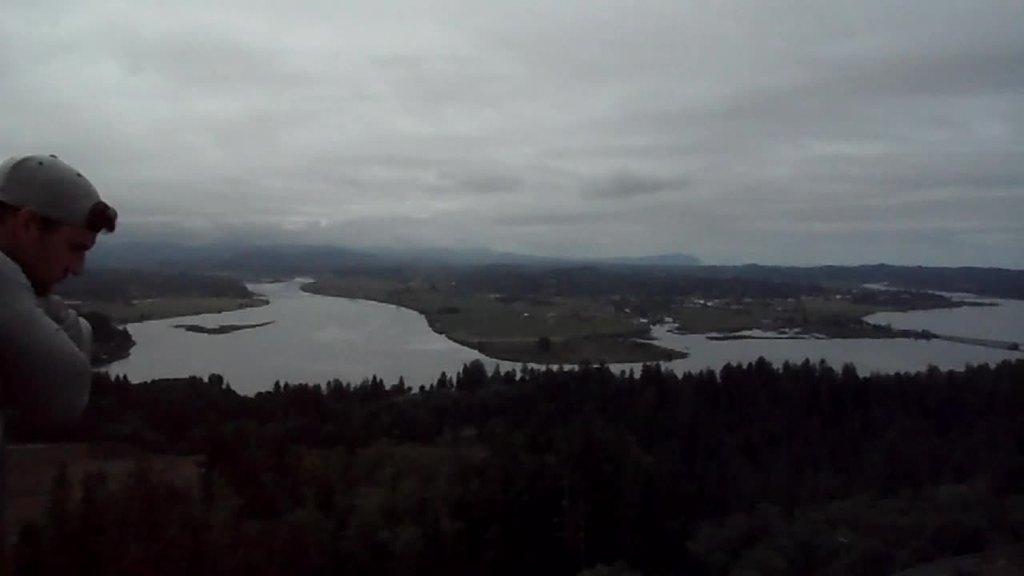Could you give a brief overview of what you see in this image? In this image there is a person , trees, water , hills , and in the background there is sky. 